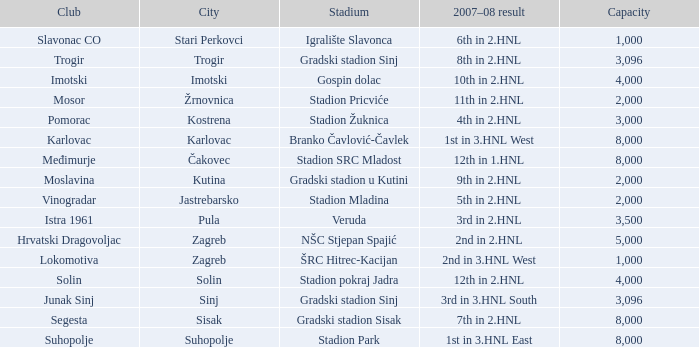What is the lowest capacity that has stadion mladina as the stadium? 2000.0. 